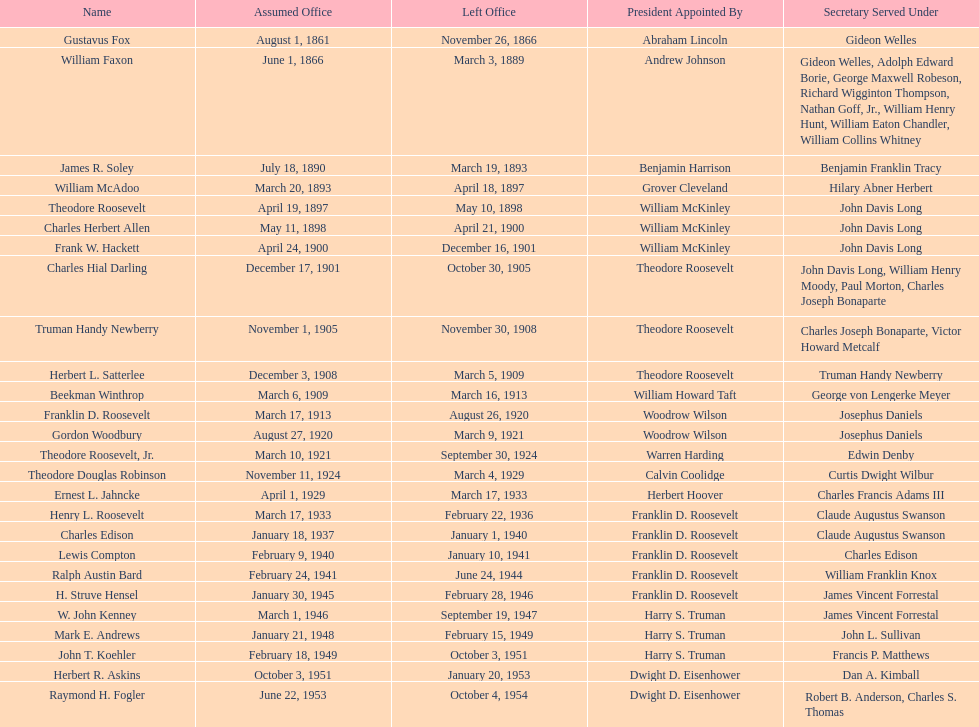Who was the first assistant secretary of the navy? Gustavus Fox. 